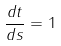<formula> <loc_0><loc_0><loc_500><loc_500>\frac { d t } { d s } = 1</formula> 